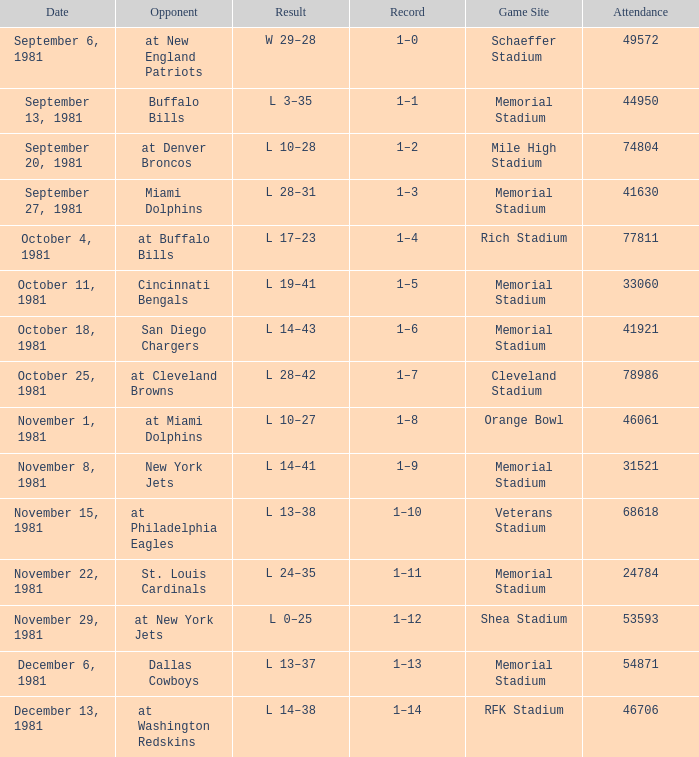At the date october 18, 1981, where can the game be found? Memorial Stadium. 